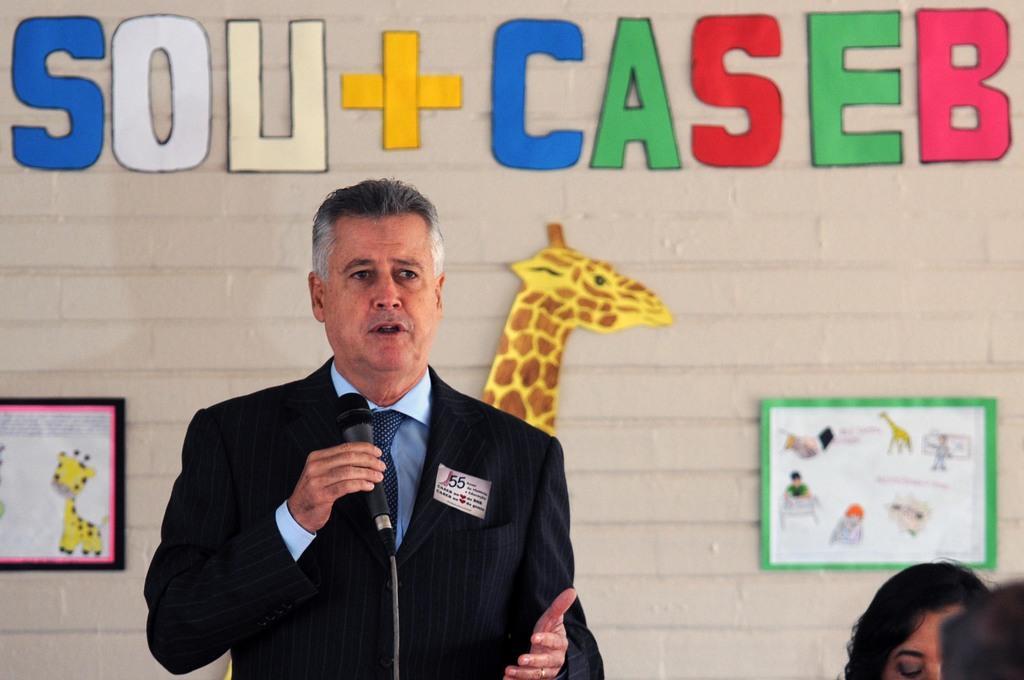Could you give a brief overview of what you see in this image? In this image I can see the person standing and holding the microphone and the person is wearing black blazer and blue color shirt. In the background I can see few charts and colorful papers attached to the wall. 